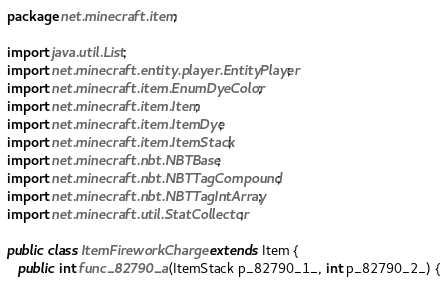Convert code to text. <code><loc_0><loc_0><loc_500><loc_500><_Java_>package net.minecraft.item;

import java.util.List;
import net.minecraft.entity.player.EntityPlayer;
import net.minecraft.item.EnumDyeColor;
import net.minecraft.item.Item;
import net.minecraft.item.ItemDye;
import net.minecraft.item.ItemStack;
import net.minecraft.nbt.NBTBase;
import net.minecraft.nbt.NBTTagCompound;
import net.minecraft.nbt.NBTTagIntArray;
import net.minecraft.util.StatCollector;

public class ItemFireworkCharge extends Item {
   public int func_82790_a(ItemStack p_82790_1_, int p_82790_2_) {</code> 